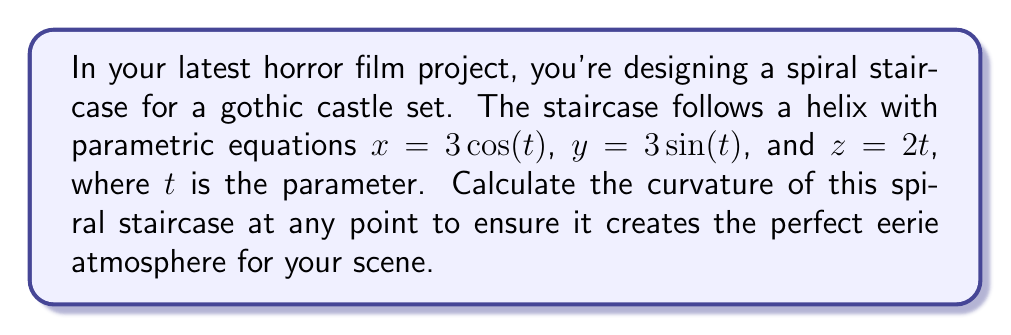Show me your answer to this math problem. To compute the curvature of the spiral staircase, we'll follow these steps:

1) The curvature $\kappa$ of a space curve is given by:

   $$\kappa = \frac{|\mathbf{r}'(t) \times \mathbf{r}''(t)|}{|\mathbf{r}'(t)|^3}$$

   where $\mathbf{r}(t)$ is the position vector.

2) First, let's find $\mathbf{r}(t)$, $\mathbf{r}'(t)$, and $\mathbf{r}''(t)$:

   $$\mathbf{r}(t) = (3\cos(t), 3\sin(t), 2t)$$
   $$\mathbf{r}'(t) = (-3\sin(t), 3\cos(t), 2)$$
   $$\mathbf{r}''(t) = (-3\cos(t), -3\sin(t), 0)$$

3) Now, let's calculate $\mathbf{r}'(t) \times \mathbf{r}''(t)$:

   $$\mathbf{r}'(t) \times \mathbf{r}''(t) = \begin{vmatrix} 
   \mathbf{i} & \mathbf{j} & \mathbf{k} \\
   -3\sin(t) & 3\cos(t) & 2 \\
   -3\cos(t) & -3\sin(t) & 0
   \end{vmatrix}$$

   $$= (-6\sin(t), -6\cos(t), -9\sin^2(t) - 9\cos^2(t))$$
   $$= (-6\sin(t), -6\cos(t), -9)$$

4) Calculate $|\mathbf{r}'(t) \times \mathbf{r}''(t)|$:

   $$|\mathbf{r}'(t) \times \mathbf{r}''(t)| = \sqrt{36\sin^2(t) + 36\cos^2(t) + 81} = \sqrt{117}$$

5) Calculate $|\mathbf{r}'(t)|$:

   $$|\mathbf{r}'(t)| = \sqrt{9\sin^2(t) + 9\cos^2(t) + 4} = \sqrt{13}$$

6) Now we can compute the curvature:

   $$\kappa = \frac{|\mathbf{r}'(t) \times \mathbf{r}''(t)|}{|\mathbf{r}'(t)|^3} = \frac{\sqrt{117}}{(\sqrt{13})^3} = \frac{\sqrt{117}}{13\sqrt{13}}$$

The curvature is constant, independent of $t$, which means the spiral staircase has the same curvature at every point.
Answer: $\frac{\sqrt{117}}{13\sqrt{13}}$ 